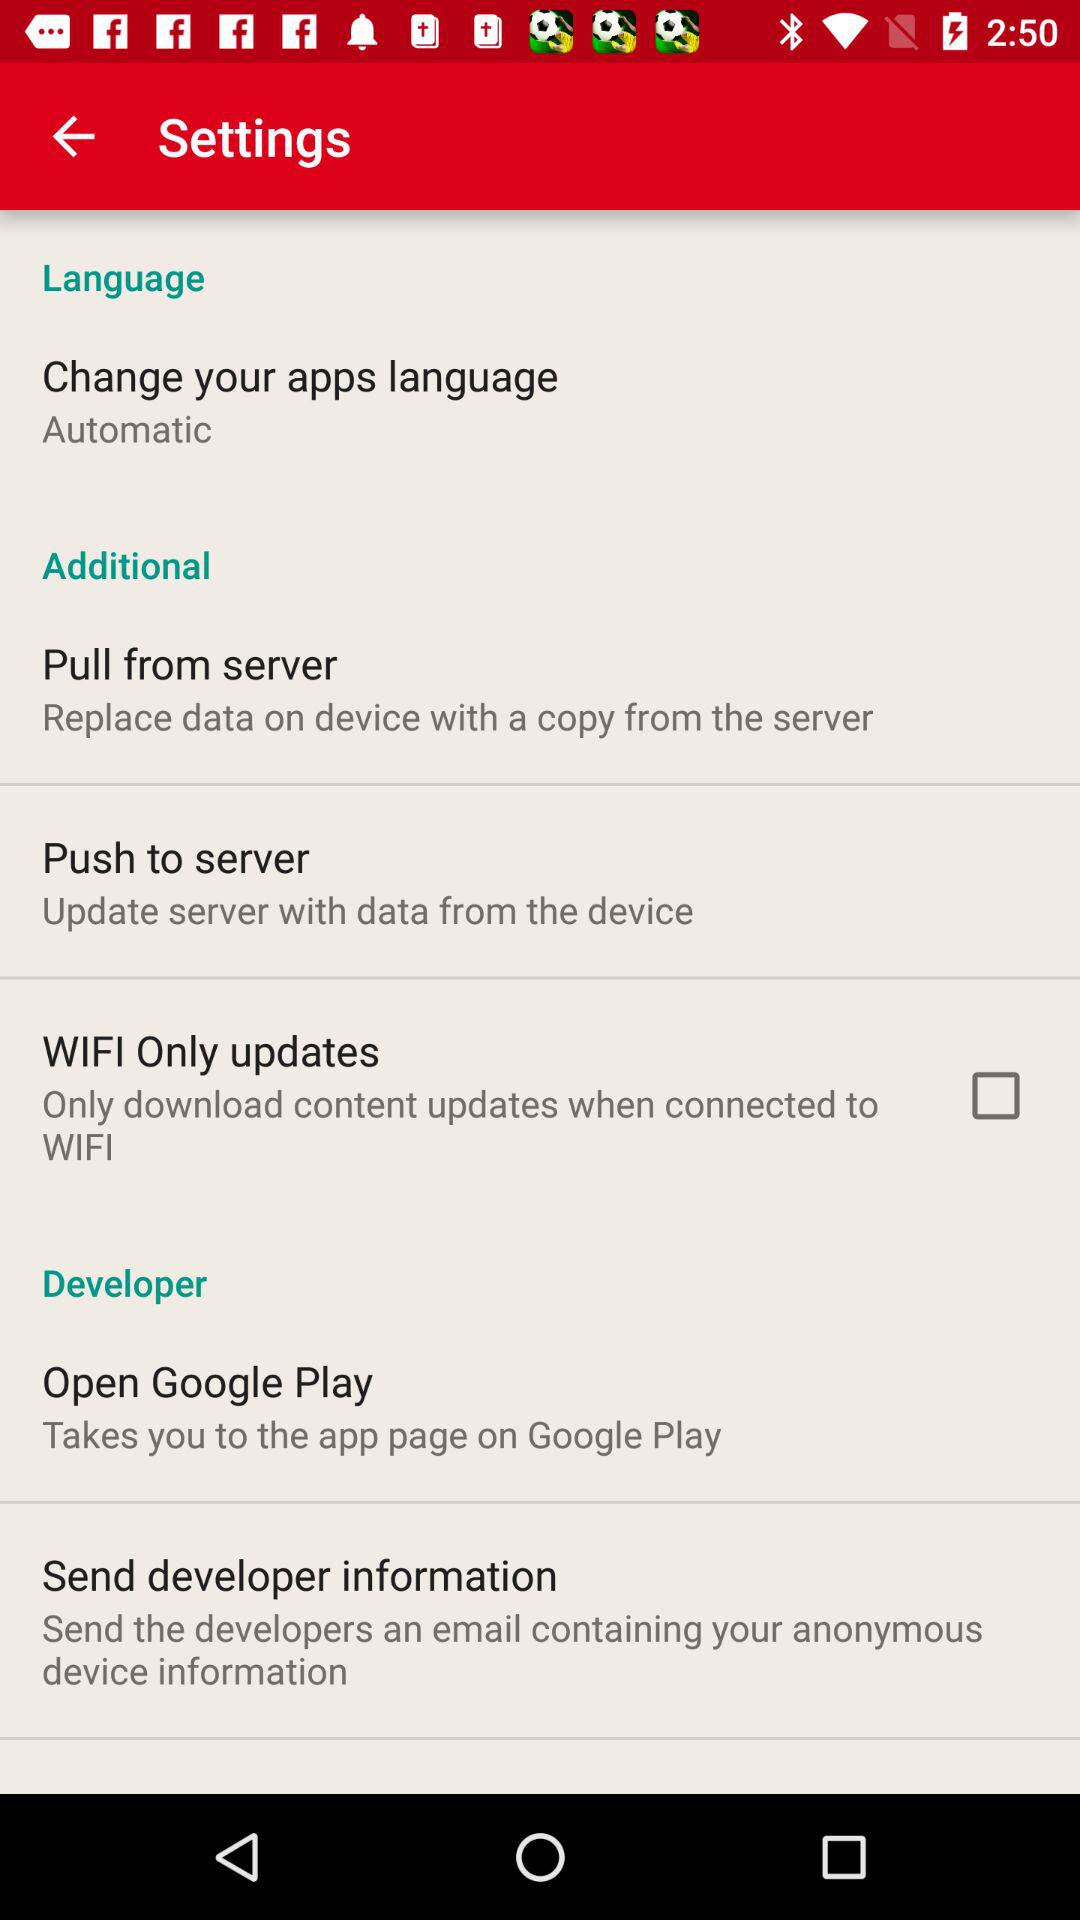What is the setting for "Change your apps language"? The setting for "Change your apps language" is "Automatic". 